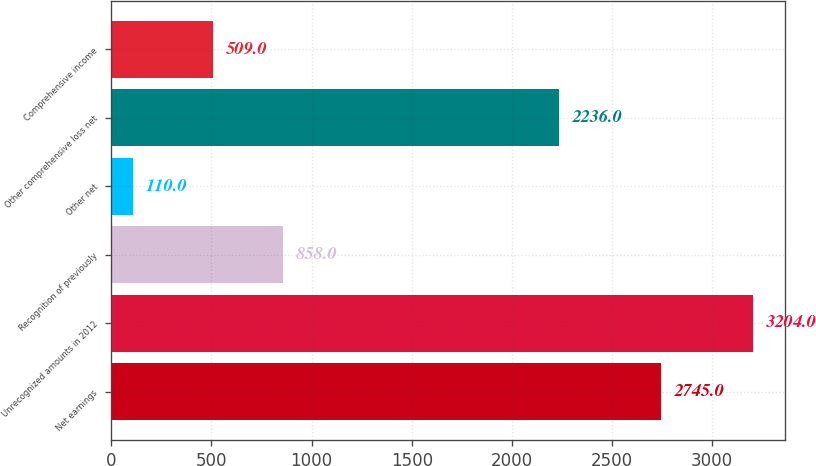Convert chart. <chart><loc_0><loc_0><loc_500><loc_500><bar_chart><fcel>Net earnings<fcel>Unrecognized amounts in 2012<fcel>Recognition of previously<fcel>Other net<fcel>Other comprehensive loss net<fcel>Comprehensive income<nl><fcel>2745<fcel>3204<fcel>858<fcel>110<fcel>2236<fcel>509<nl></chart> 